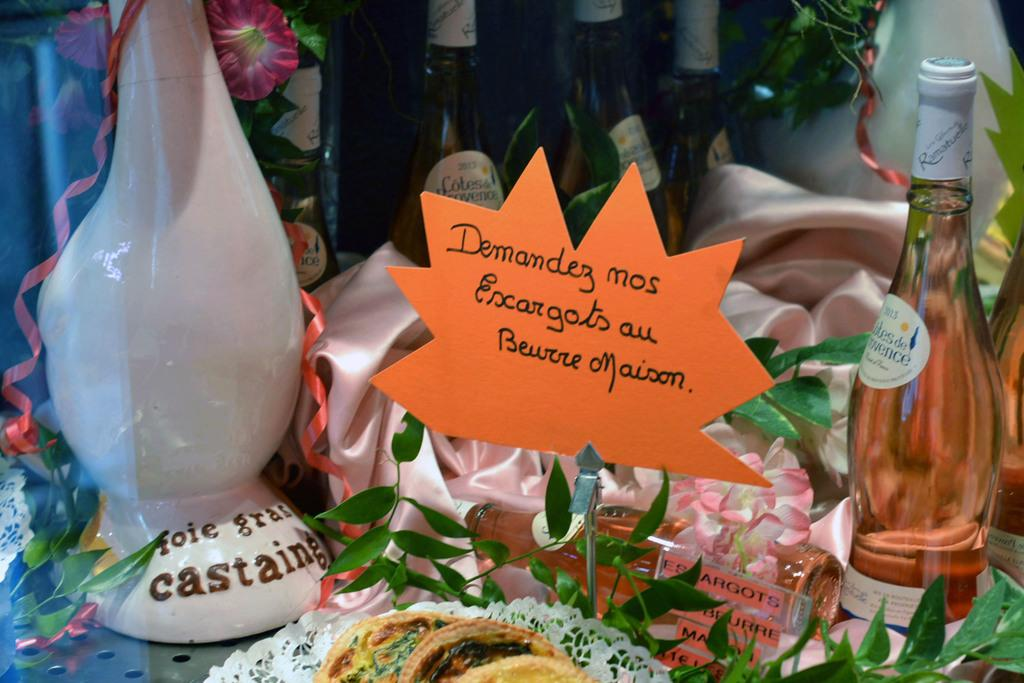<image>
Offer a succinct explanation of the picture presented. A bunch of small items are on display, including an orange sign that has text starting with Demandez. 